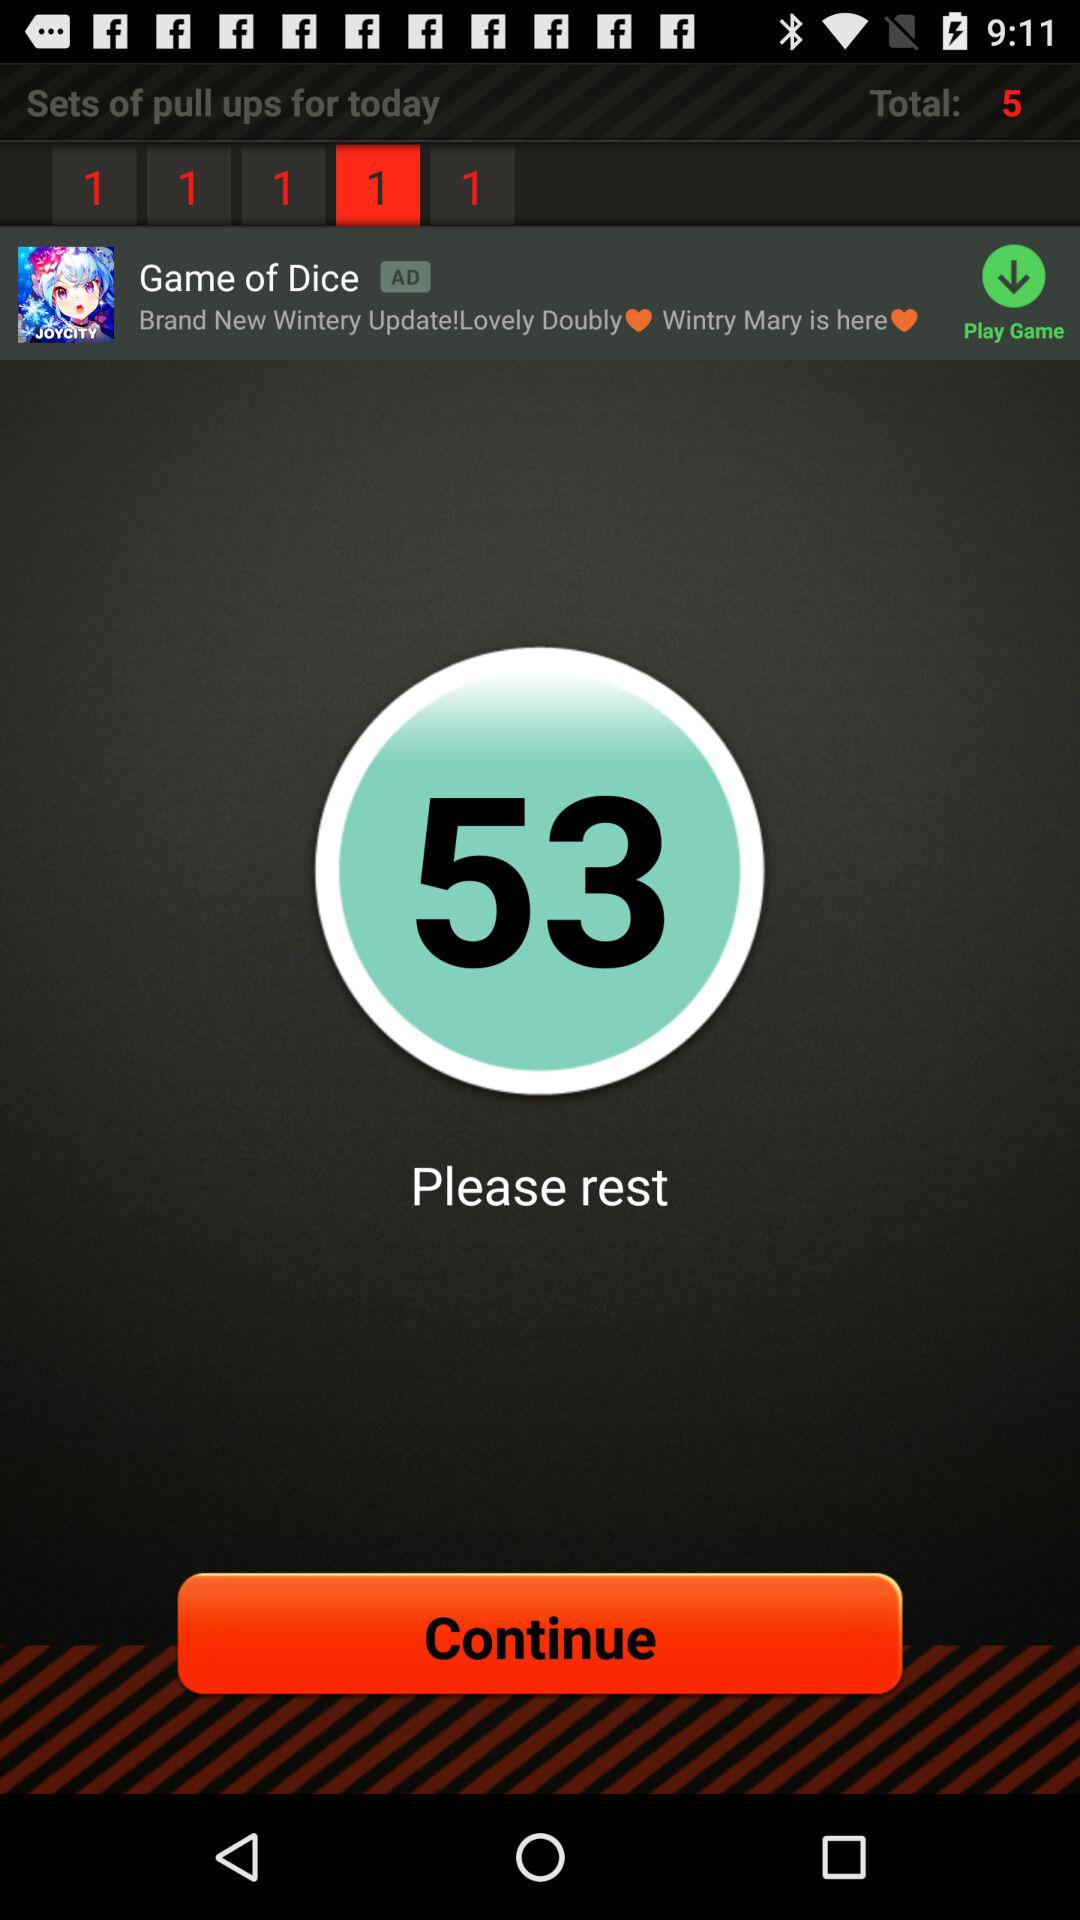How many sets of pull-ups are there for today? There are 5 sets of pull-ups for today. 